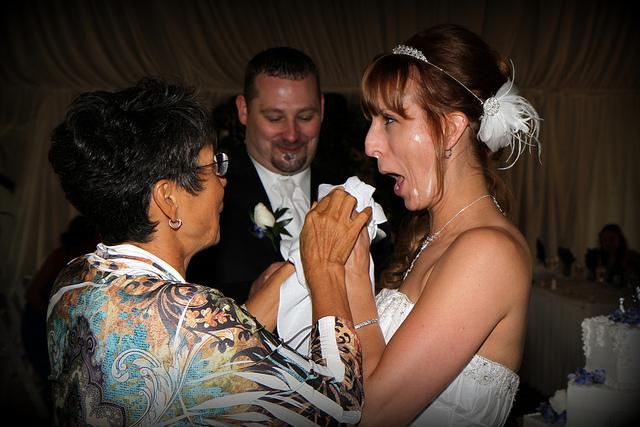Why is the woman wiping her face?
Answer briefly. Crying. What is the man wearing?
Keep it brief. Tuxedo. What type of function is this?
Keep it brief. Wedding. Does the woman have a tan?
Write a very short answer. No. What is the man doing?
Write a very short answer. Smiling. 